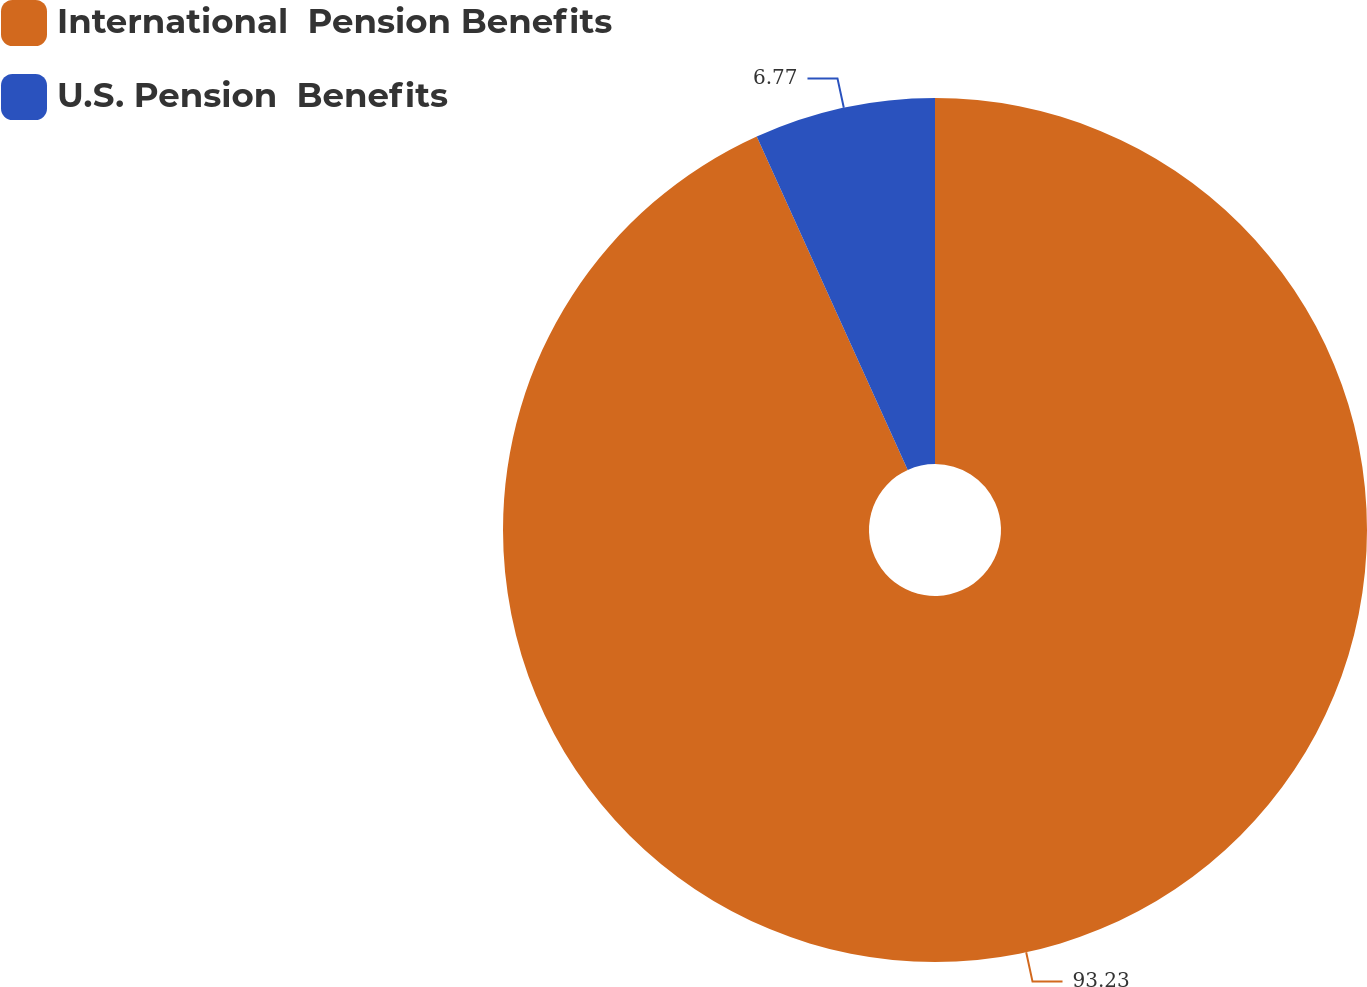Convert chart. <chart><loc_0><loc_0><loc_500><loc_500><pie_chart><fcel>International  Pension Benefits<fcel>U.S. Pension  Benefits<nl><fcel>93.23%<fcel>6.77%<nl></chart> 